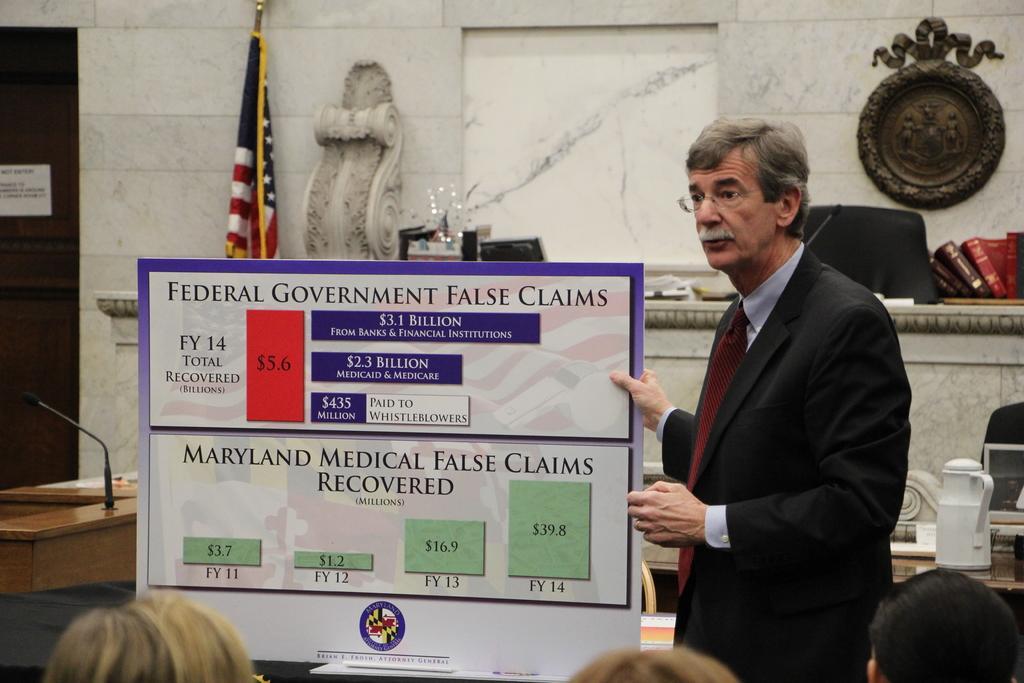Please provide a concise description of this image. In this image I can see a person standing wearing white shirt, maroon tie holding a board which is in white color and something written on it. Background I can see flag in blue, white and red color, and wall in white color. 